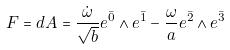Convert formula to latex. <formula><loc_0><loc_0><loc_500><loc_500>F = d A = \frac { \dot { \omega } } { \sqrt { b } } e ^ { \bar { 0 } } \wedge e ^ { \bar { 1 } } - \frac { \omega } { a } e ^ { \bar { 2 } } \wedge e ^ { \bar { 3 } }</formula> 